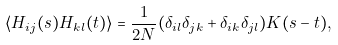Convert formula to latex. <formula><loc_0><loc_0><loc_500><loc_500>\langle H _ { i j } ( s ) H _ { k l } ( t ) \rangle = \frac { 1 } { 2 N } ( \delta _ { i l } \delta _ { j k } + \delta _ { i k } \delta _ { j l } ) K ( s - t ) ,</formula> 